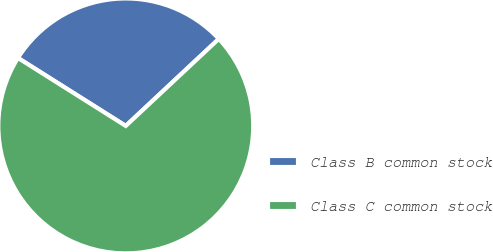Convert chart. <chart><loc_0><loc_0><loc_500><loc_500><pie_chart><fcel>Class B common stock<fcel>Class C common stock<nl><fcel>29.08%<fcel>70.92%<nl></chart> 